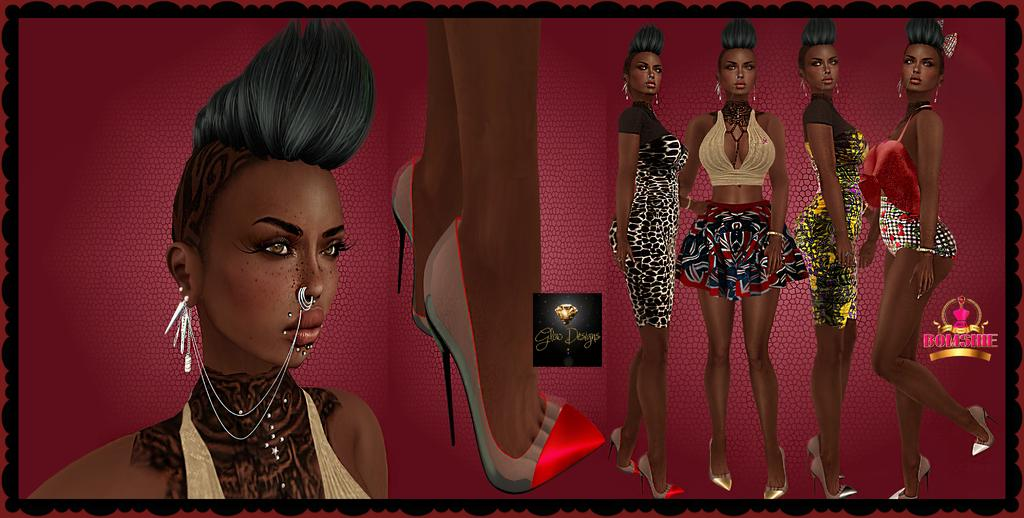What type of image is being described? The image is an animated picture. What can be seen in terms of people in the image? There are women standing in the image. Are there any words or letters in the image? Yes, there is text present in the image. What can be observed about the footwear of a person in the image? The legs of a person wearing sandals are visible in the middle portion of the image. What type of fang can be seen in the image? There is no fang present in the image. Can you tell me what time of day it is in the image? The time of day cannot be determined from the image. 